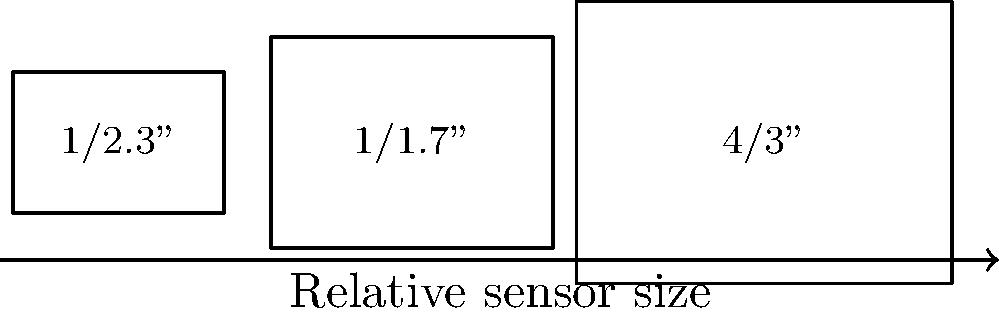As a camera equipment specialist, you are comparing different sensor sizes. The diagram shows three common sensor sizes used in digital cameras. Based on the relative sizes shown, approximately how many times larger is the area of a 4/3" sensor compared to a 1/2.3" sensor? To determine the relative area difference between the 4/3" and 1/2.3" sensors, we'll follow these steps:

1. Estimate the dimensions of each sensor from the diagram:
   - 1/2.3": approximately 3.6 units wide and 2.4 units tall
   - 4/3": approximately 6.4 units wide and 4.8 units tall

2. Calculate the area of each sensor:
   - Area of 1/2.3" sensor: $A_1 = 3.6 \times 2.4 = 8.64$ square units
   - Area of 4/3" sensor: $A_2 = 6.4 \times 4.8 = 30.72$ square units

3. Calculate the ratio of the areas:
   $\text{Ratio} = \frac{A_2}{A_1} = \frac{30.72}{8.64} \approx 3.56$

Therefore, the 4/3" sensor is approximately 3.56 times larger in area than the 1/2.3" sensor.

Rounding to the nearest whole number, we can say that the 4/3" sensor is about 4 times larger in area than the 1/2.3" sensor.
Answer: 4 times larger 